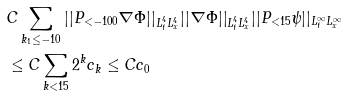Convert formula to latex. <formula><loc_0><loc_0><loc_500><loc_500>& C \sum _ { k _ { 1 } \leq - 1 0 } | | P _ { < - 1 0 0 } \nabla \Phi | | _ { L _ { t } ^ { 4 } L _ { x } ^ { 4 } } | | \nabla \Phi | | _ { L _ { t } ^ { 4 } L _ { x } ^ { 4 } } | | P _ { < 1 5 } \psi | | _ { L _ { t } ^ { \infty } L _ { x } ^ { \infty } } \\ & \leq C \sum _ { k < 1 5 } 2 ^ { k } c _ { k } \leq C c _ { 0 } \\</formula> 